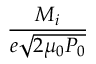<formula> <loc_0><loc_0><loc_500><loc_500>\frac { M _ { i } } { e \sqrt { 2 \mu _ { 0 } P _ { 0 } } }</formula> 